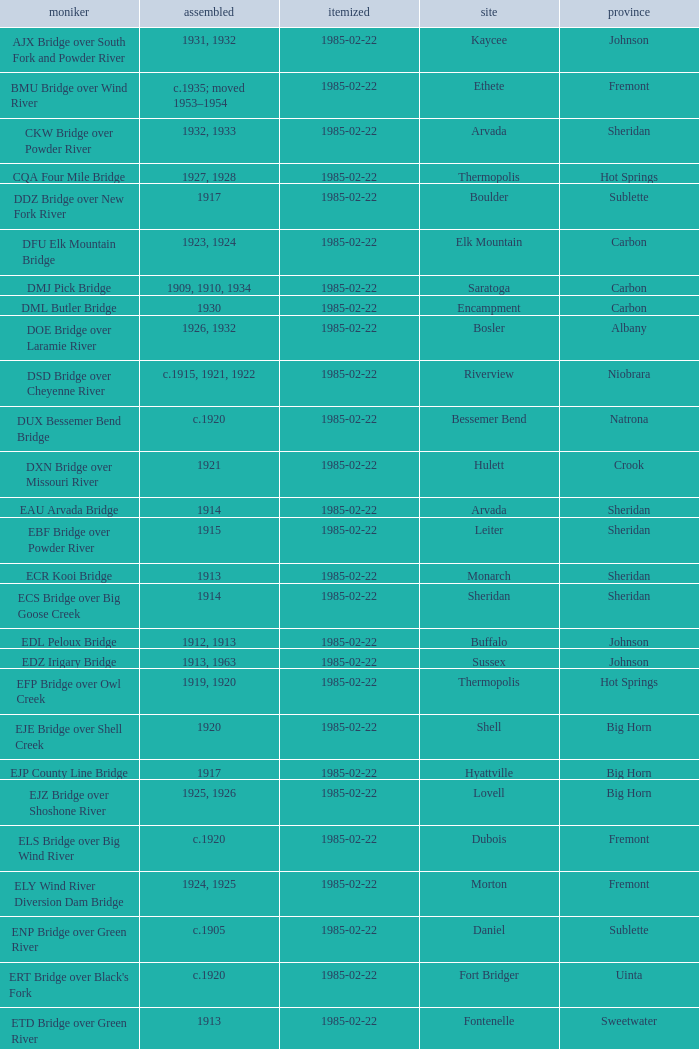What is the listed for the bridge at Daniel in Sublette county? 1985-02-22. Can you parse all the data within this table? {'header': ['moniker', 'assembled', 'itemized', 'site', 'province'], 'rows': [['AJX Bridge over South Fork and Powder River', '1931, 1932', '1985-02-22', 'Kaycee', 'Johnson'], ['BMU Bridge over Wind River', 'c.1935; moved 1953–1954', '1985-02-22', 'Ethete', 'Fremont'], ['CKW Bridge over Powder River', '1932, 1933', '1985-02-22', 'Arvada', 'Sheridan'], ['CQA Four Mile Bridge', '1927, 1928', '1985-02-22', 'Thermopolis', 'Hot Springs'], ['DDZ Bridge over New Fork River', '1917', '1985-02-22', 'Boulder', 'Sublette'], ['DFU Elk Mountain Bridge', '1923, 1924', '1985-02-22', 'Elk Mountain', 'Carbon'], ['DMJ Pick Bridge', '1909, 1910, 1934', '1985-02-22', 'Saratoga', 'Carbon'], ['DML Butler Bridge', '1930', '1985-02-22', 'Encampment', 'Carbon'], ['DOE Bridge over Laramie River', '1926, 1932', '1985-02-22', 'Bosler', 'Albany'], ['DSD Bridge over Cheyenne River', 'c.1915, 1921, 1922', '1985-02-22', 'Riverview', 'Niobrara'], ['DUX Bessemer Bend Bridge', 'c.1920', '1985-02-22', 'Bessemer Bend', 'Natrona'], ['DXN Bridge over Missouri River', '1921', '1985-02-22', 'Hulett', 'Crook'], ['EAU Arvada Bridge', '1914', '1985-02-22', 'Arvada', 'Sheridan'], ['EBF Bridge over Powder River', '1915', '1985-02-22', 'Leiter', 'Sheridan'], ['ECR Kooi Bridge', '1913', '1985-02-22', 'Monarch', 'Sheridan'], ['ECS Bridge over Big Goose Creek', '1914', '1985-02-22', 'Sheridan', 'Sheridan'], ['EDL Peloux Bridge', '1912, 1913', '1985-02-22', 'Buffalo', 'Johnson'], ['EDZ Irigary Bridge', '1913, 1963', '1985-02-22', 'Sussex', 'Johnson'], ['EFP Bridge over Owl Creek', '1919, 1920', '1985-02-22', 'Thermopolis', 'Hot Springs'], ['EJE Bridge over Shell Creek', '1920', '1985-02-22', 'Shell', 'Big Horn'], ['EJP County Line Bridge', '1917', '1985-02-22', 'Hyattville', 'Big Horn'], ['EJZ Bridge over Shoshone River', '1925, 1926', '1985-02-22', 'Lovell', 'Big Horn'], ['ELS Bridge over Big Wind River', 'c.1920', '1985-02-22', 'Dubois', 'Fremont'], ['ELY Wind River Diversion Dam Bridge', '1924, 1925', '1985-02-22', 'Morton', 'Fremont'], ['ENP Bridge over Green River', 'c.1905', '1985-02-22', 'Daniel', 'Sublette'], ["ERT Bridge over Black's Fork", 'c.1920', '1985-02-22', 'Fort Bridger', 'Uinta'], ['ETD Bridge over Green River', '1913', '1985-02-22', 'Fontenelle', 'Sweetwater'], ['ETR Big Island Bridge', '1909, 1910', '1985-02-22', 'Green River', 'Sweetwater'], ['EWZ Bridge over East Channel of Laramie River', '1913, 1914', '1985-02-22', 'Wheatland', 'Platte'], ['Hayden Arch Bridge', '1924, 1925', '1985-02-22', 'Cody', 'Park'], ['Rairden Bridge', '1916', '1985-02-22', 'Manderson', 'Big Horn']]} 